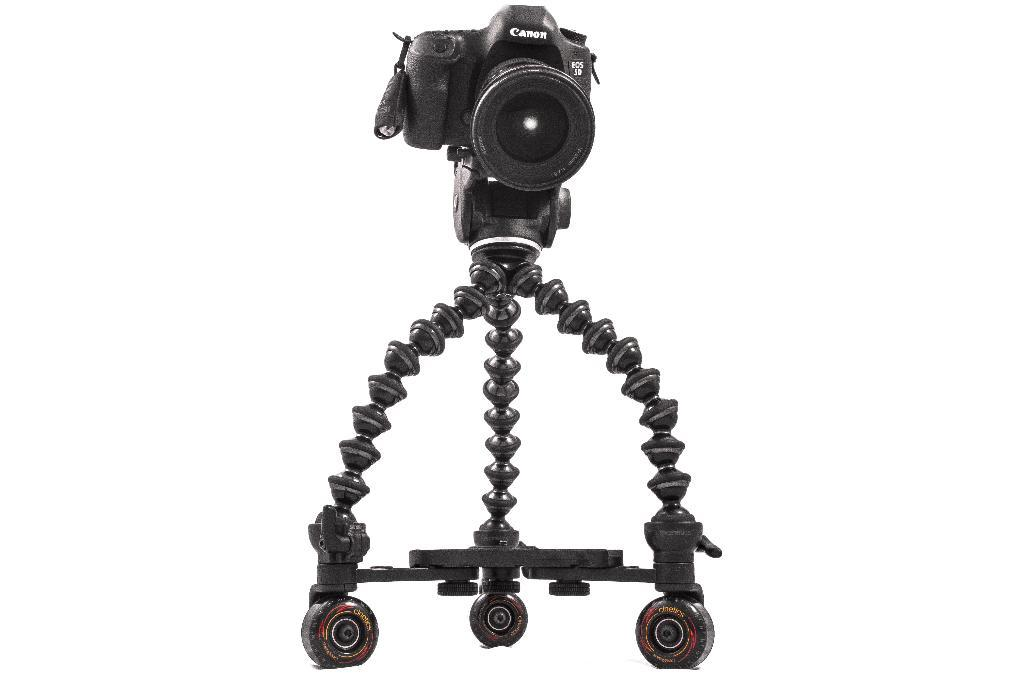What type of stand is in the image? There is a gorillapod stand in the image. What is attached to the stand? A camera is present on the stand. What color is the background of the image? The background of the image is white. What type of weather can be seen in the image? There is no weather depicted in the image, as it is a close-up shot of a gorillapod stand with a camera attached. 